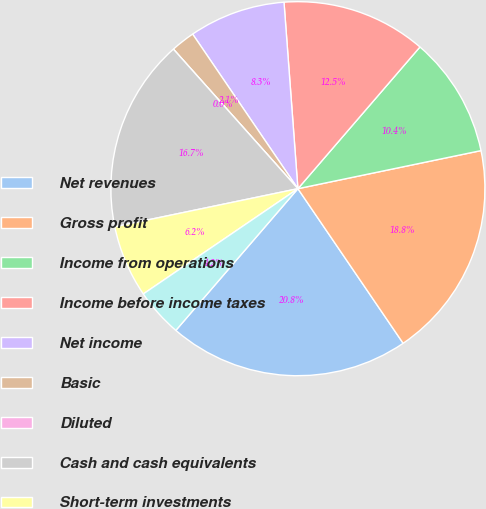Convert chart to OTSL. <chart><loc_0><loc_0><loc_500><loc_500><pie_chart><fcel>Net revenues<fcel>Gross profit<fcel>Income from operations<fcel>Income before income taxes<fcel>Net income<fcel>Basic<fcel>Diluted<fcel>Cash and cash equivalents<fcel>Short-term investments<fcel>Long-term investments<nl><fcel>20.83%<fcel>18.75%<fcel>10.42%<fcel>12.5%<fcel>8.33%<fcel>2.08%<fcel>0.0%<fcel>16.67%<fcel>6.25%<fcel>4.17%<nl></chart> 